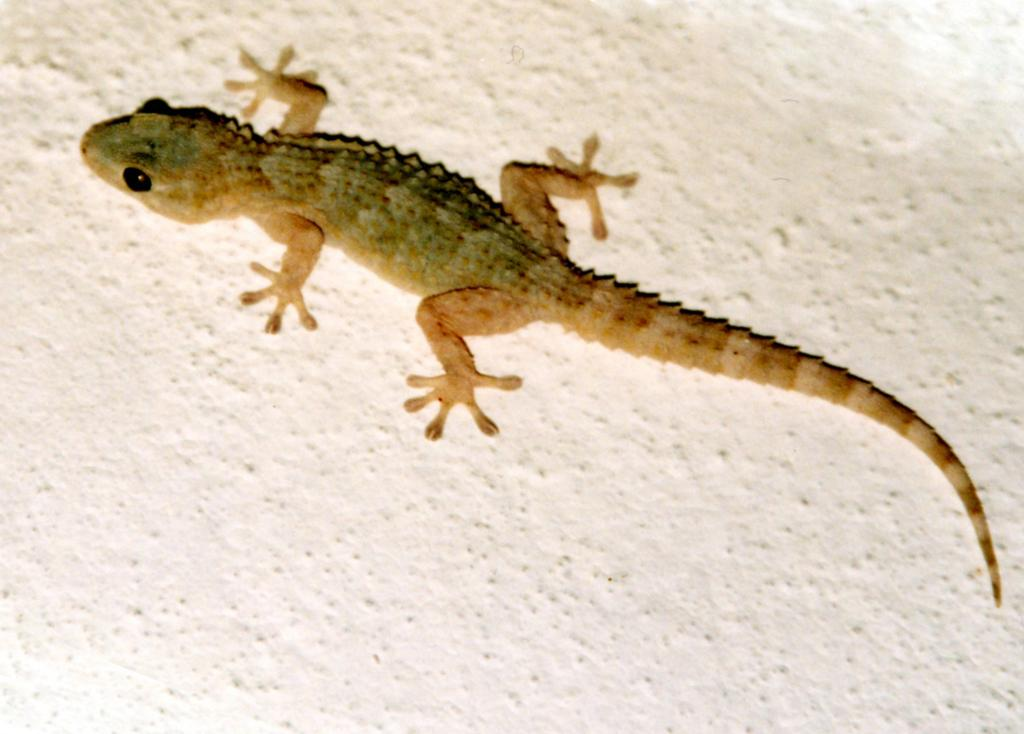What animal is present in the image? There is a lizard in the image. Where is the lizard located? The lizard is on a white wall. What colors can be seen on the lizard? The lizard has brown and green colors. What type of owl can be seen perched on the lizard's back in the image? There is no owl present in the image; it only features a lizard on a white wall. 